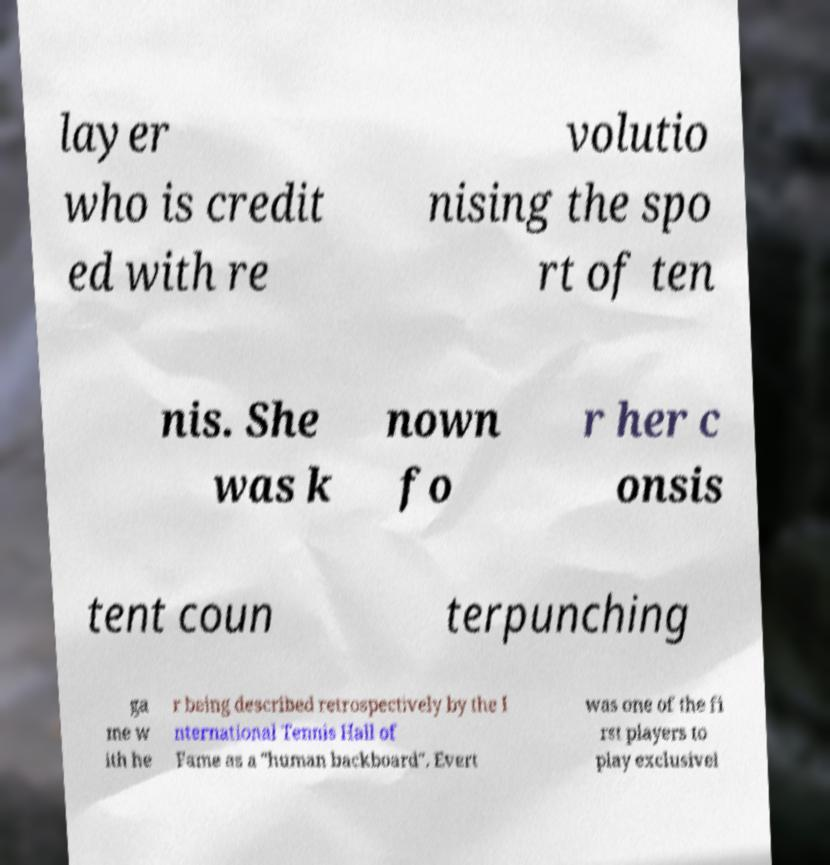Can you read and provide the text displayed in the image?This photo seems to have some interesting text. Can you extract and type it out for me? layer who is credit ed with re volutio nising the spo rt of ten nis. She was k nown fo r her c onsis tent coun terpunching ga me w ith he r being described retrospectively by the I nternational Tennis Hall of Fame as a "human backboard". Evert was one of the fi rst players to play exclusivel 